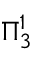<formula> <loc_0><loc_0><loc_500><loc_500>\Pi _ { 3 } ^ { 1 }</formula> 